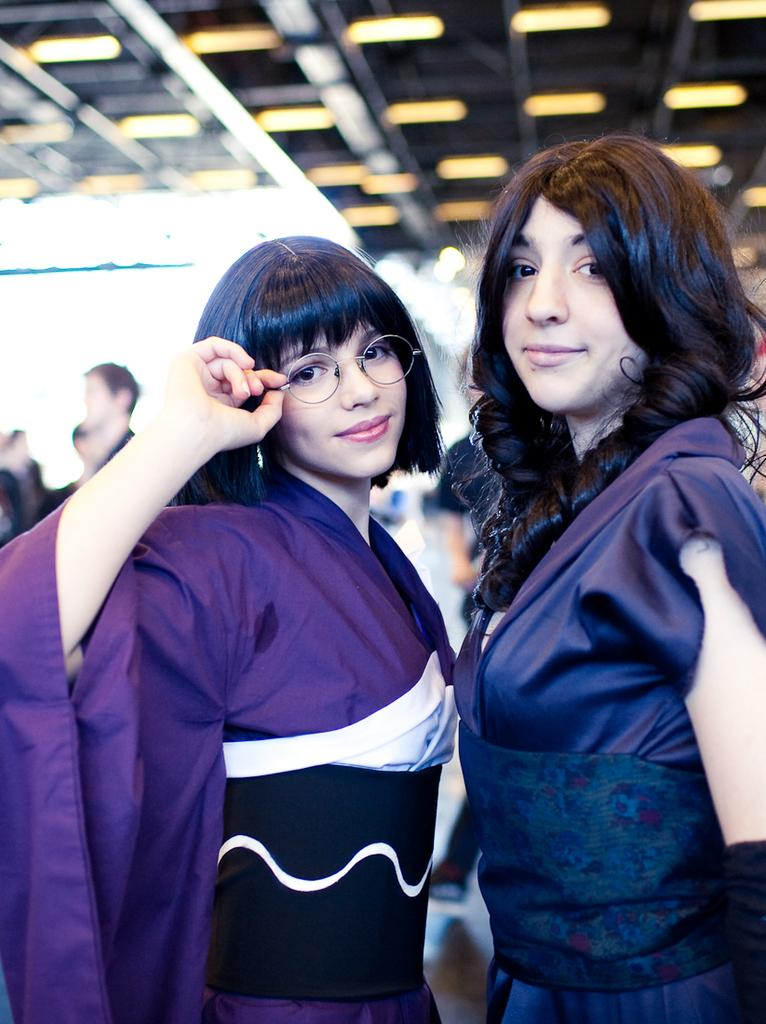How many women are in the image? There are two women in the image. What are the women wearing? The women are wearing violet dresses. What can be seen in the background of the image? There is a group of people in the background of the image. What is on top of the building in the image? There is a roof visible in the image, and there are lights on the roof. What type of sack can be seen in the image? There is no sack present in the image. What kind of rice is being cooked on the roof in the image? There is no rice or cooking activity visible in the image; the lights on the roof are not related to cooking. 